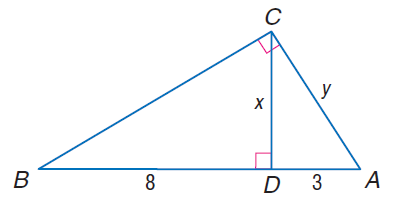Answer the mathemtical geometry problem and directly provide the correct option letter.
Question: Find y.
Choices: A: \sqrt { 29 } B: \sqrt { 31 } C: \sqrt { 33 } D: \sqrt { 35 } C 